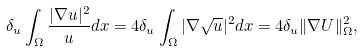Convert formula to latex. <formula><loc_0><loc_0><loc_500><loc_500>\delta _ { u } \int _ { \Omega } \frac { | \nabla u | ^ { 2 } } { u } d x = 4 \delta _ { u } \int _ { \Omega } | \nabla \sqrt { u } | ^ { 2 } d x = 4 \delta _ { u } \| \nabla U \| _ { \Omega } ^ { 2 } ,</formula> 